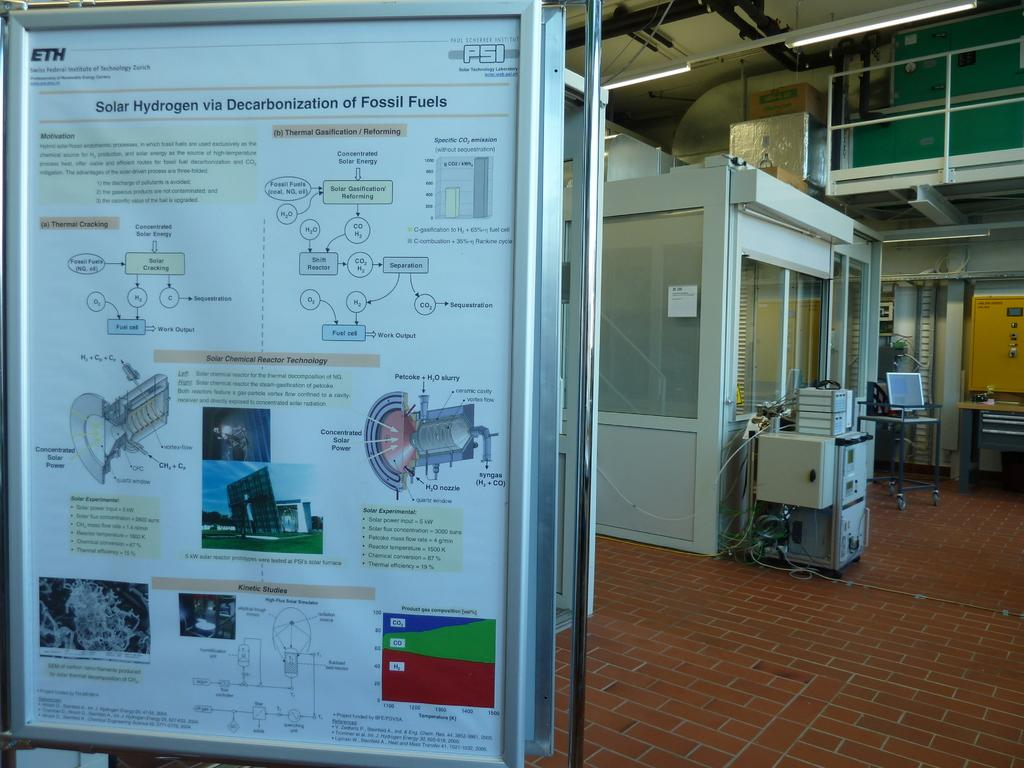<image>
Present a compact description of the photo's key features. An informational poster provides a detailed explanation for the subject of Solar Hydrogen via Decarbonization of Fossil Fuels. 